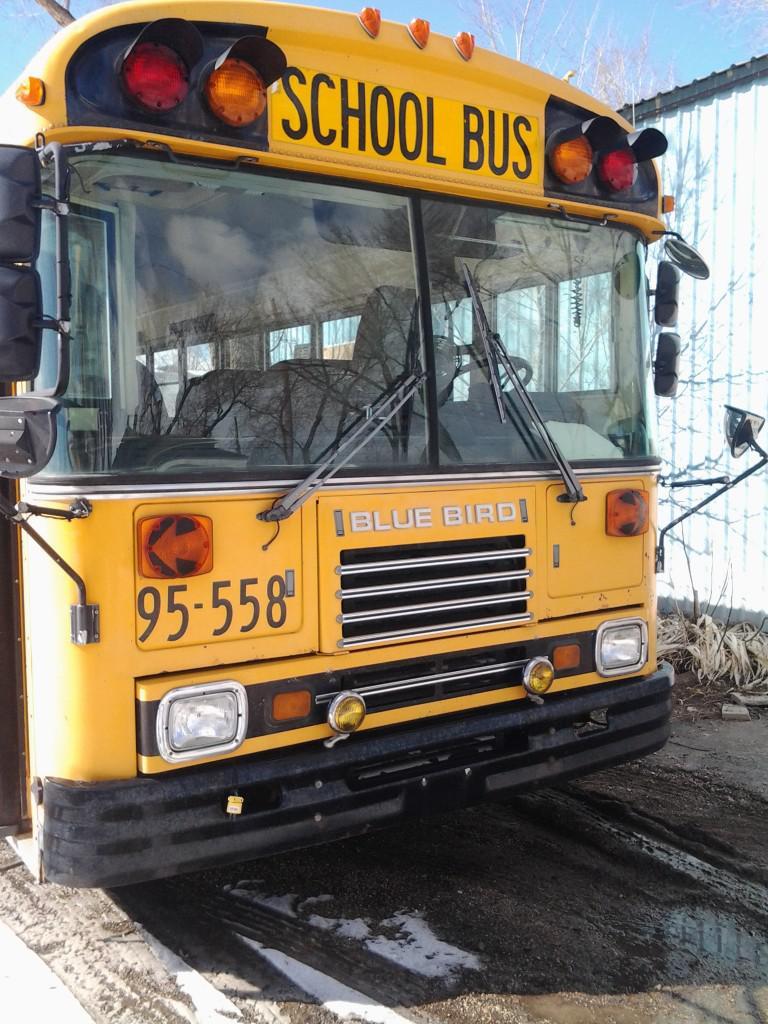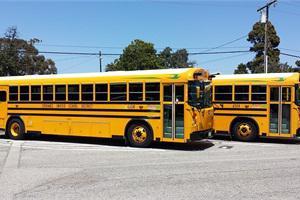The first image is the image on the left, the second image is the image on the right. Examine the images to the left and right. Is the description "In the right image, a rightward-facing yellow bus appears to be colliding with something else that is yellow." accurate? Answer yes or no. No. 